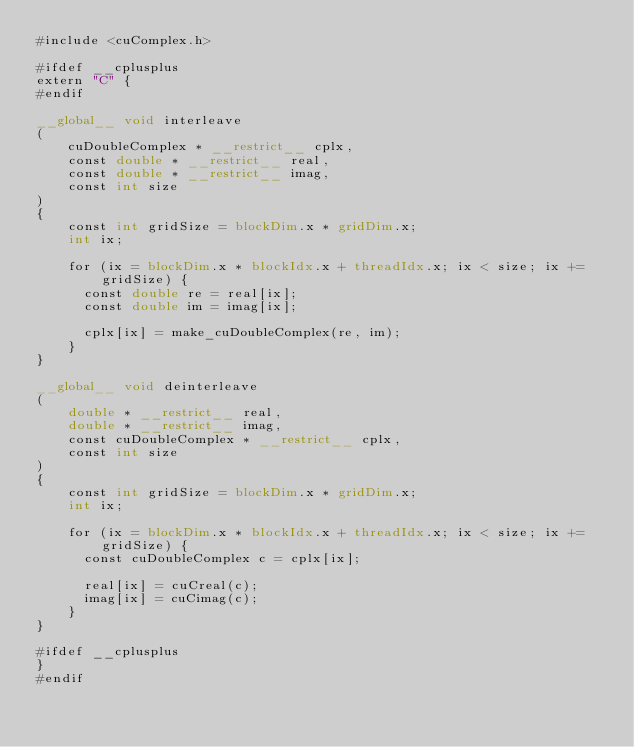<code> <loc_0><loc_0><loc_500><loc_500><_Cuda_>#include <cuComplex.h>

#ifdef __cplusplus
extern "C" {
#endif

__global__ void interleave
(
    cuDoubleComplex * __restrict__ cplx,
    const double * __restrict__ real,
    const double * __restrict__ imag,
    const int size
)
{
    const int gridSize = blockDim.x * gridDim.x;
    int ix;

    for (ix = blockDim.x * blockIdx.x + threadIdx.x; ix < size; ix += gridSize) {
      const double re = real[ix];
      const double im = imag[ix];

      cplx[ix] = make_cuDoubleComplex(re, im);
    }
}

__global__ void deinterleave
(
    double * __restrict__ real,
    double * __restrict__ imag,
    const cuDoubleComplex * __restrict__ cplx,
    const int size
)
{
    const int gridSize = blockDim.x * gridDim.x;
    int ix;

    for (ix = blockDim.x * blockIdx.x + threadIdx.x; ix < size; ix += gridSize) {
      const cuDoubleComplex c = cplx[ix];

      real[ix] = cuCreal(c);
      imag[ix] = cuCimag(c);
    }
}

#ifdef __cplusplus
}
#endif

</code> 